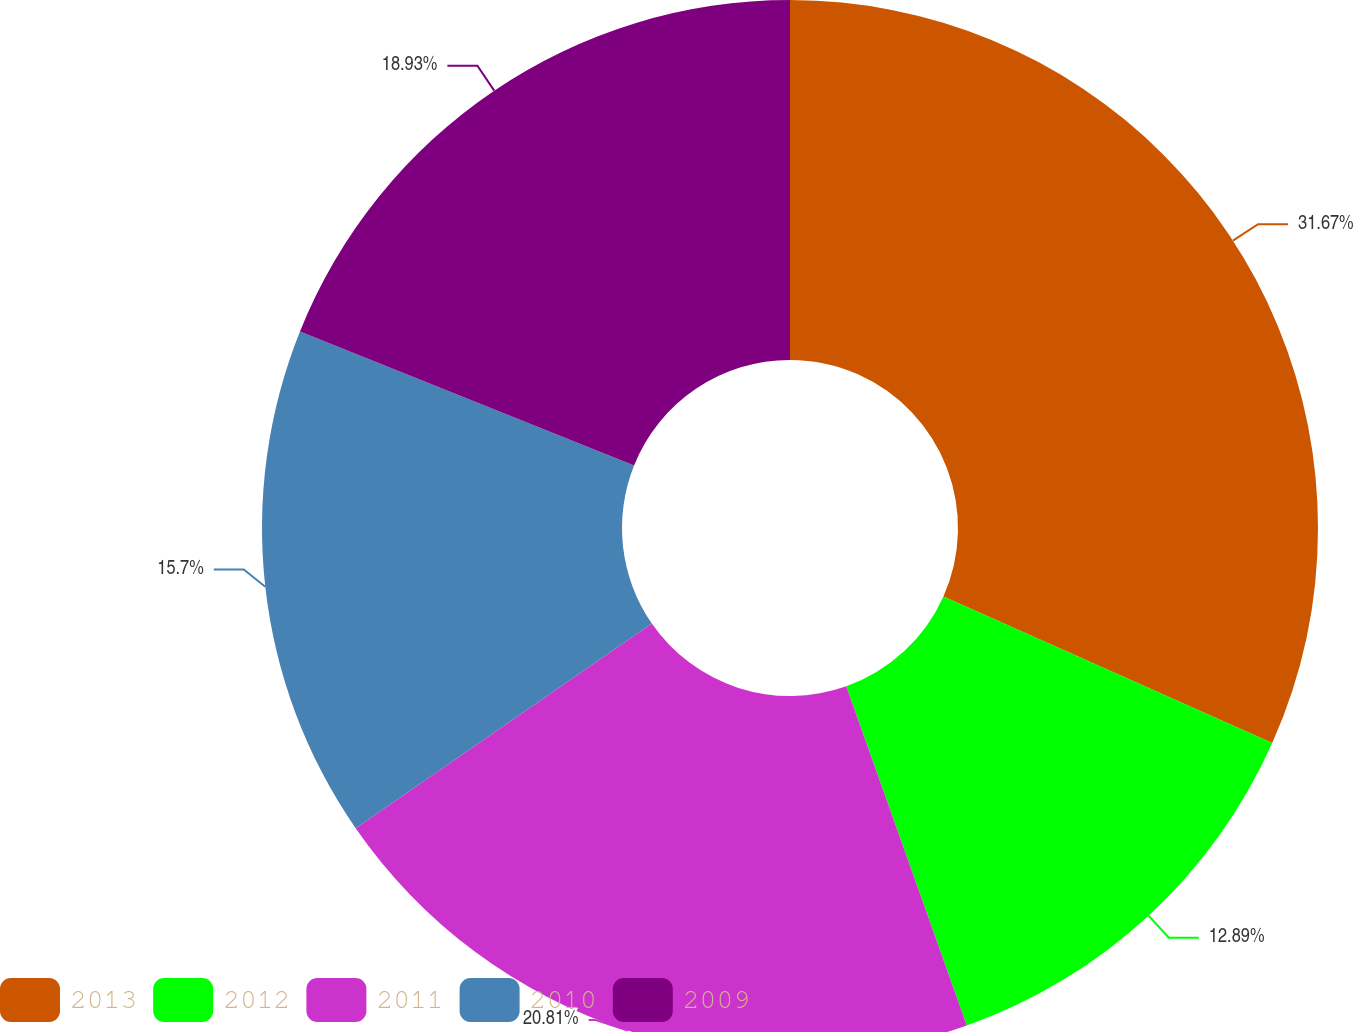Convert chart. <chart><loc_0><loc_0><loc_500><loc_500><pie_chart><fcel>2013<fcel>2012<fcel>2011<fcel>2010<fcel>2009<nl><fcel>31.68%<fcel>12.89%<fcel>20.81%<fcel>15.7%<fcel>18.93%<nl></chart> 